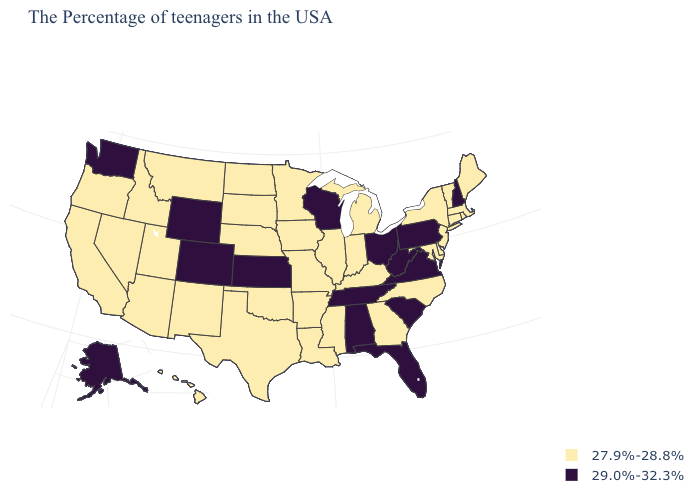What is the highest value in states that border Florida?
Be succinct. 29.0%-32.3%. What is the value of Hawaii?
Short answer required. 27.9%-28.8%. Does Minnesota have the lowest value in the MidWest?
Concise answer only. Yes. What is the highest value in the South ?
Quick response, please. 29.0%-32.3%. Does the first symbol in the legend represent the smallest category?
Keep it brief. Yes. Name the states that have a value in the range 29.0%-32.3%?
Keep it brief. New Hampshire, Pennsylvania, Virginia, South Carolina, West Virginia, Ohio, Florida, Alabama, Tennessee, Wisconsin, Kansas, Wyoming, Colorado, Washington, Alaska. Name the states that have a value in the range 29.0%-32.3%?
Keep it brief. New Hampshire, Pennsylvania, Virginia, South Carolina, West Virginia, Ohio, Florida, Alabama, Tennessee, Wisconsin, Kansas, Wyoming, Colorado, Washington, Alaska. What is the highest value in the South ?
Answer briefly. 29.0%-32.3%. Name the states that have a value in the range 27.9%-28.8%?
Be succinct. Maine, Massachusetts, Rhode Island, Vermont, Connecticut, New York, New Jersey, Delaware, Maryland, North Carolina, Georgia, Michigan, Kentucky, Indiana, Illinois, Mississippi, Louisiana, Missouri, Arkansas, Minnesota, Iowa, Nebraska, Oklahoma, Texas, South Dakota, North Dakota, New Mexico, Utah, Montana, Arizona, Idaho, Nevada, California, Oregon, Hawaii. Is the legend a continuous bar?
Answer briefly. No. What is the value of South Carolina?
Answer briefly. 29.0%-32.3%. Does New Jersey have the highest value in the Northeast?
Write a very short answer. No. What is the value of Kansas?
Answer briefly. 29.0%-32.3%. What is the value of Iowa?
Answer briefly. 27.9%-28.8%. What is the value of Rhode Island?
Answer briefly. 27.9%-28.8%. 